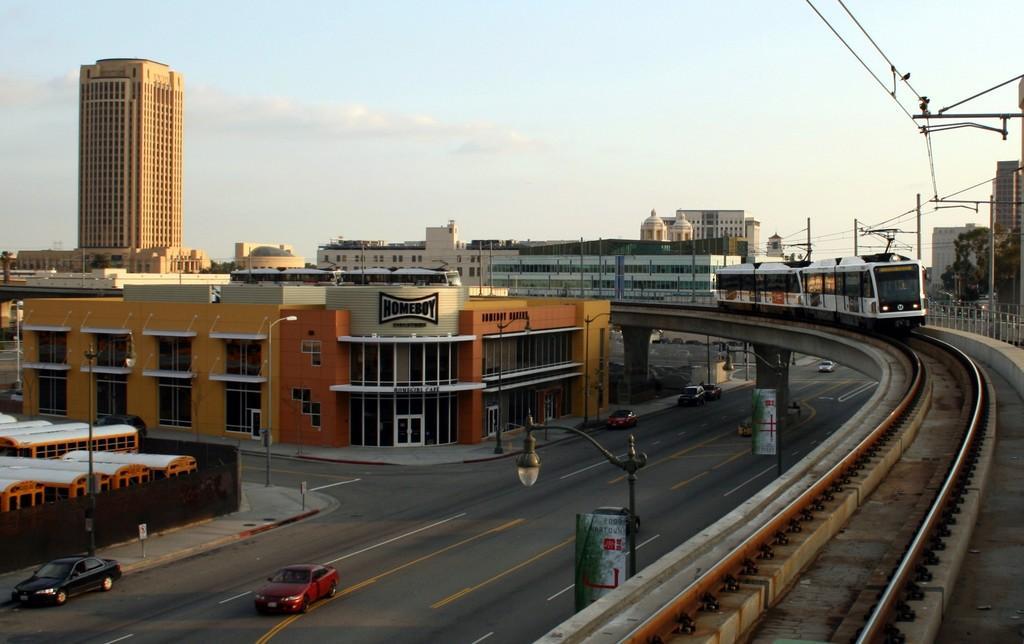Describe this image in one or two sentences. In this image there is a metro train on the right side. On the left side there are buildings. At the bottom there is a road on which there are vehicles. There are electric poles with the lights on the footpath. At the top there is the sky. On the right side there are electric poles. On the left side there is a tall building. On the right side bottom there is a railway track. 